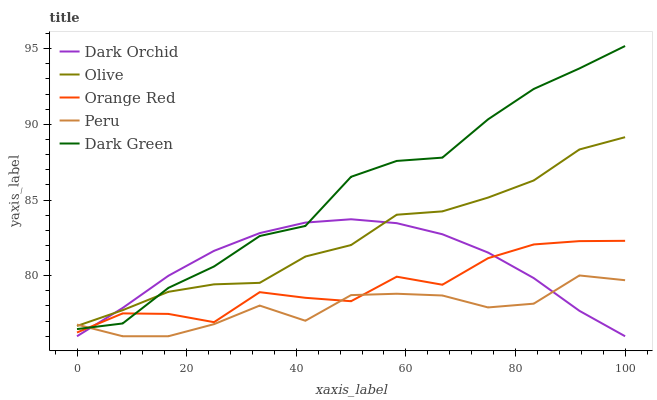Does Peru have the minimum area under the curve?
Answer yes or no. Yes. Does Dark Green have the maximum area under the curve?
Answer yes or no. Yes. Does Orange Red have the minimum area under the curve?
Answer yes or no. No. Does Orange Red have the maximum area under the curve?
Answer yes or no. No. Is Dark Orchid the smoothest?
Answer yes or no. Yes. Is Orange Red the roughest?
Answer yes or no. Yes. Is Peru the smoothest?
Answer yes or no. No. Is Peru the roughest?
Answer yes or no. No. Does Peru have the lowest value?
Answer yes or no. Yes. Does Orange Red have the lowest value?
Answer yes or no. No. Does Dark Green have the highest value?
Answer yes or no. Yes. Does Orange Red have the highest value?
Answer yes or no. No. Is Orange Red less than Olive?
Answer yes or no. Yes. Is Olive greater than Orange Red?
Answer yes or no. Yes. Does Dark Orchid intersect Orange Red?
Answer yes or no. Yes. Is Dark Orchid less than Orange Red?
Answer yes or no. No. Is Dark Orchid greater than Orange Red?
Answer yes or no. No. Does Orange Red intersect Olive?
Answer yes or no. No. 